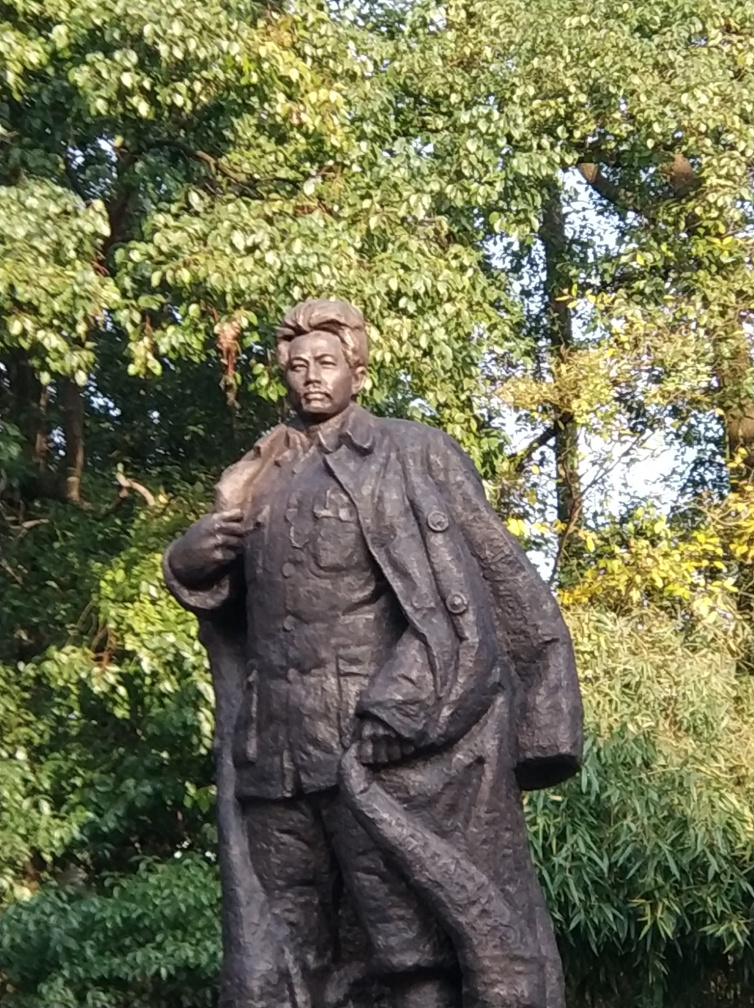What details can you provide about the statue? The statue appears to be a bronze figure of a man standing upright. His facial expression is solemn, and he is dressed in what seems to be a military or formal attire, suggesting that he might be a figure of historical significance or a revered leader. There's a naturalistic style in its composition, and the backdrop of lush trees indicates that the statue is situated outdoors, possibly in a park or a public space dedicated to his memory. 